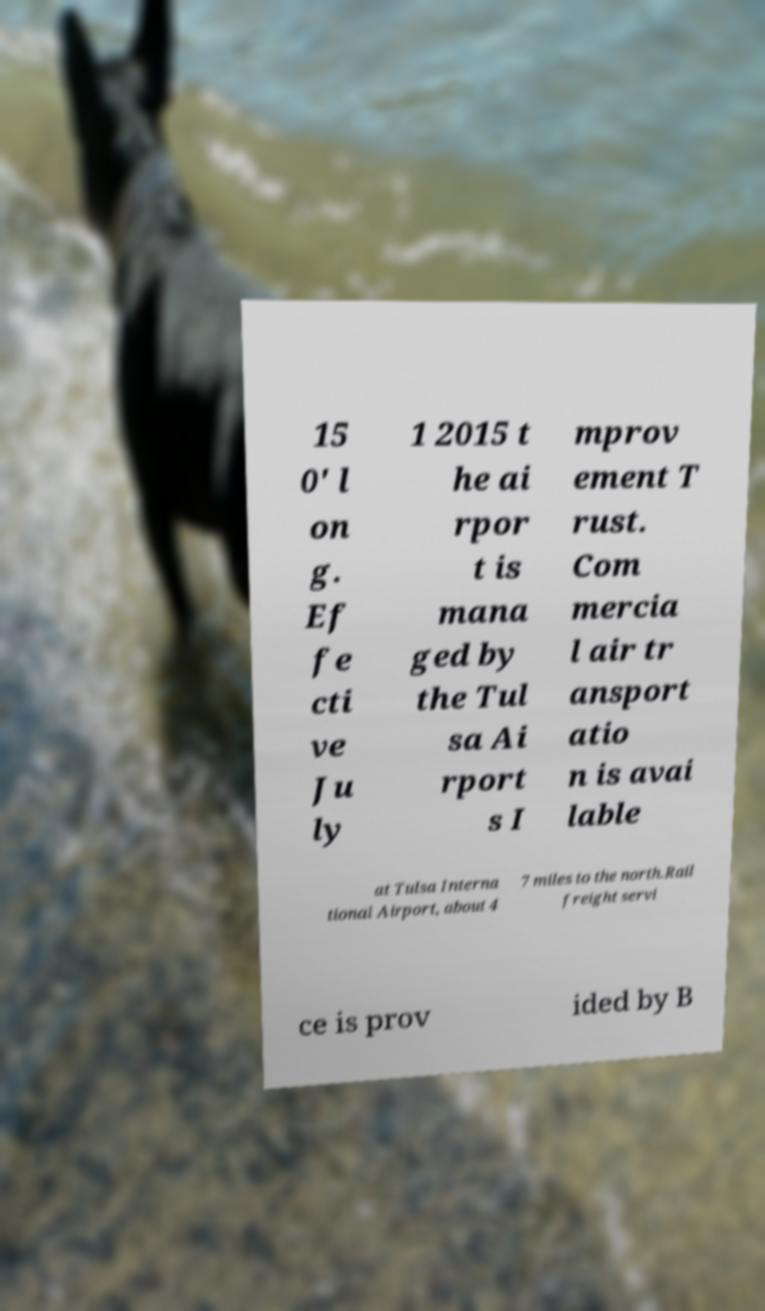Could you extract and type out the text from this image? 15 0' l on g. Ef fe cti ve Ju ly 1 2015 t he ai rpor t is mana ged by the Tul sa Ai rport s I mprov ement T rust. Com mercia l air tr ansport atio n is avai lable at Tulsa Interna tional Airport, about 4 7 miles to the north.Rail freight servi ce is prov ided by B 